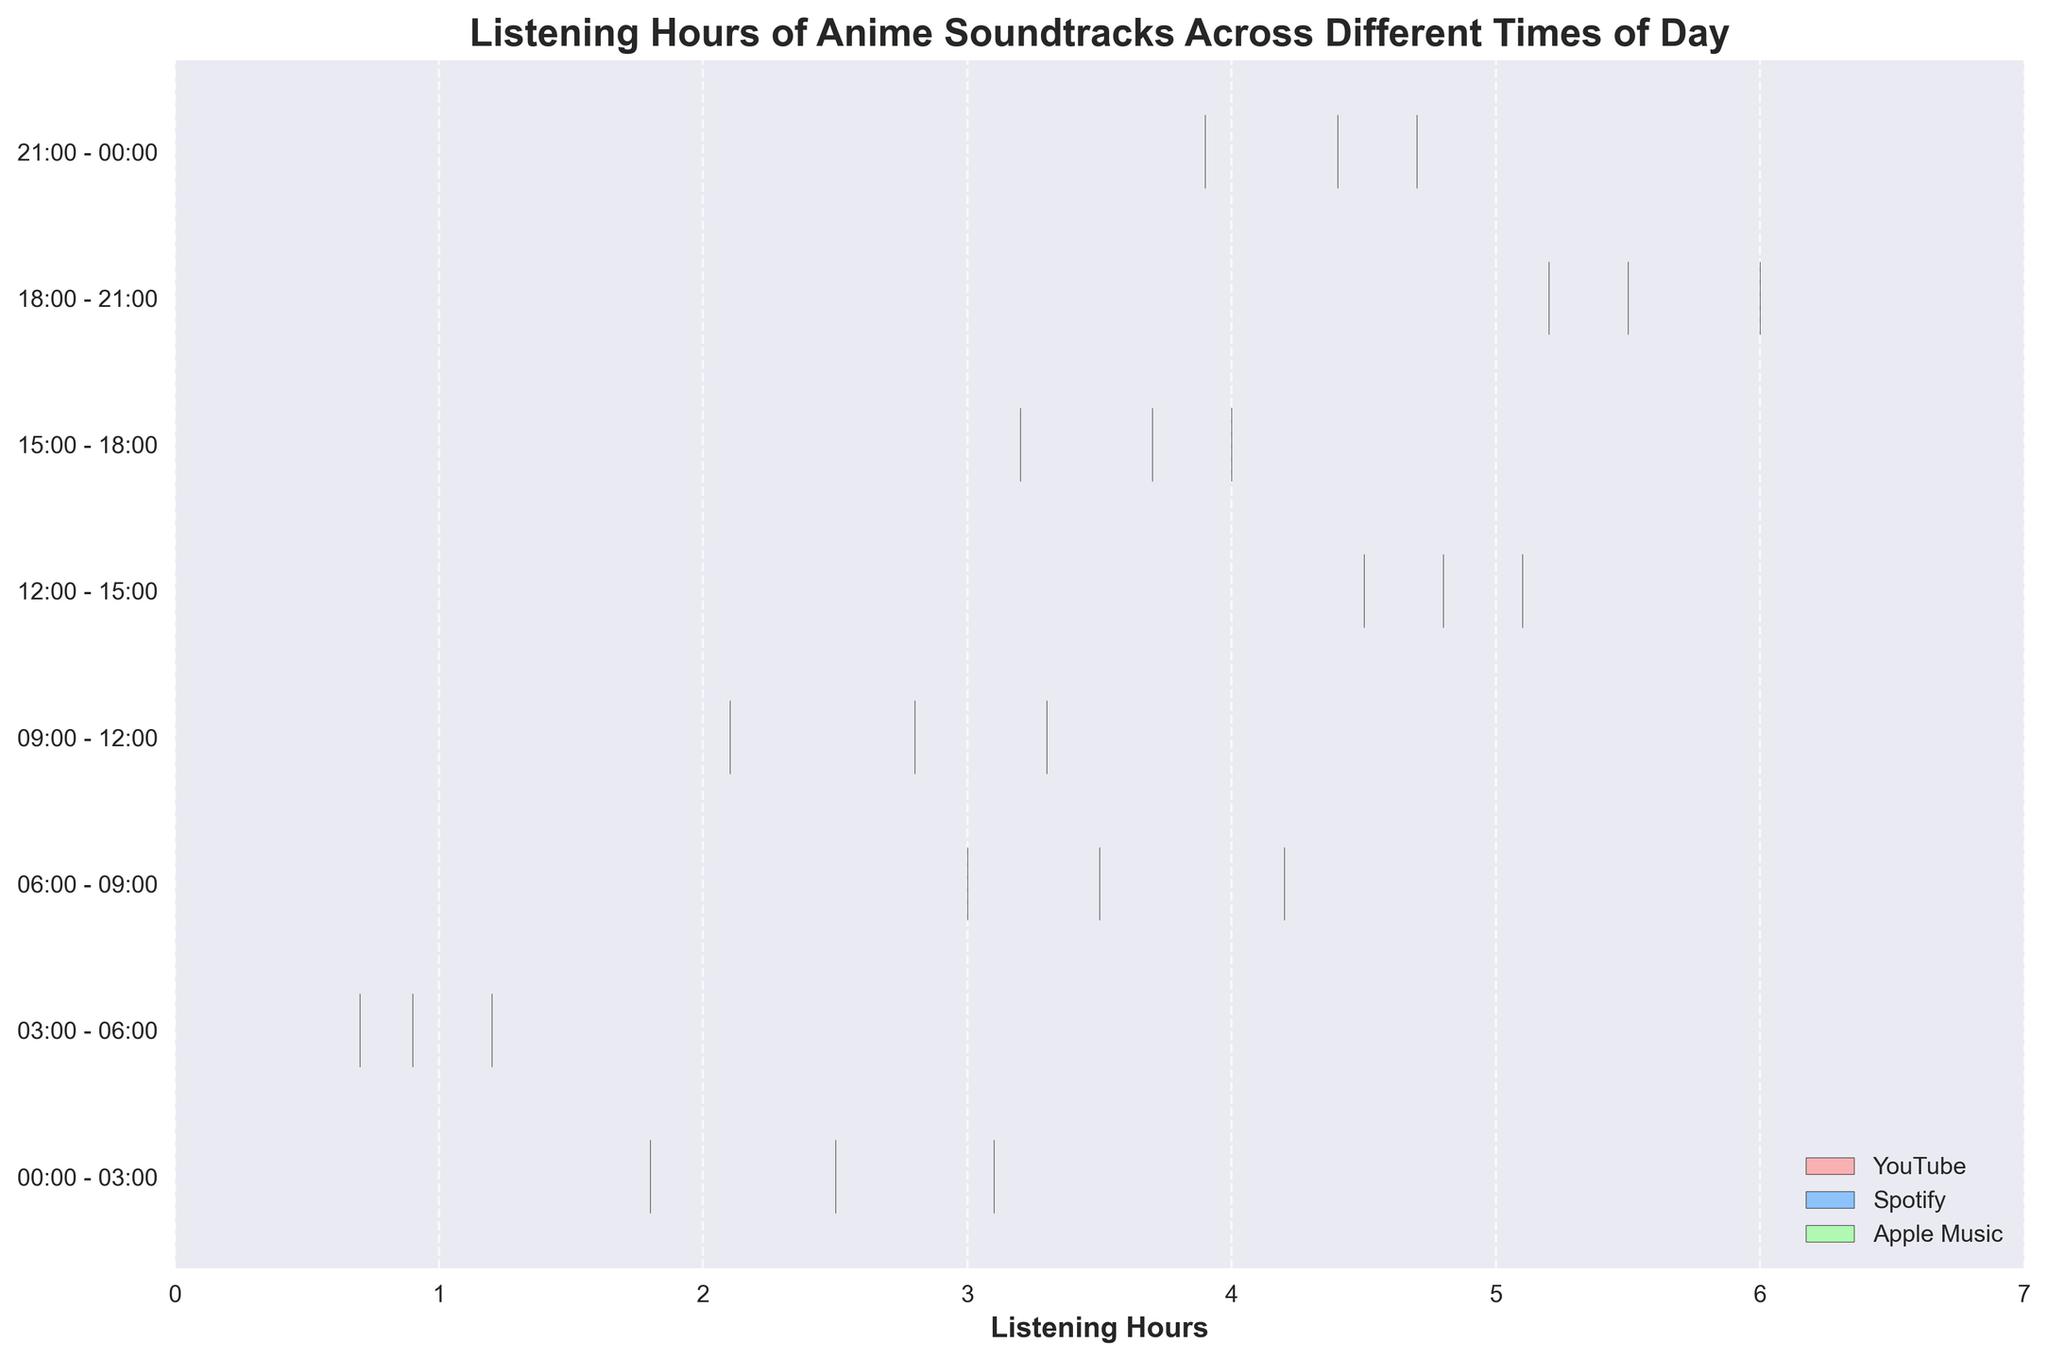Which time of day shows the highest listening hours for anime soundtracks on YouTube? The chart title is "Listening Hours of Anime Soundtracks Across Different Times of Day". By analyzing the shades of the violin plots across different time intervals and colors, the time of day with the highest listening hours for YouTube can be identified by finding the widest plot region for YouTube’s color.
Answer: 18:00 - 21:00 How do the listening hours of Spotify between 12:00 - 15:00 and 21:00 - 00:00 compare? The chart uses different colors for each source. To compare Spotify, identify the corresponding color and observe the widths of the violin plots at these two times. Between 12:00 - 15:00, Spotify shows a wider distribution compared to 21:00 - 00:00.
Answer: 12:00 - 15:00 is higher What is the average listening hour of anime soundtracks on Apple Music from 00:00 - 03:00 to 03:00 - 06:00? Add the listening hours for Apple Music from 00:00 - 03:00 (1.8 hours) and 03:00 - 06:00 (0.9 hours), then divide by 2. The average is (1.8 + 0.9) / 2.
Answer: 1.35 hours During which period do people listen to the least anime soundtracks on Apple Music? The chart details periods and their violin width based on Apple Music's color. The narrowest section represents the least listening hours. The smallest plot for any time period for Apple Music (green) is from 03:00 - 06:00.
Answer: 03:00 - 06:00 Which source has the most consistent listening hours across all times of the day? Consistency here means minimum fluctuation in the widths of the violin plots throughout the day. Observing the chart, Spotify (blue) maintains a more uniform width than the others, showing less variation in listening hours.
Answer: Spotify What are the median listening hours for anime soundtracks on YouTube between 09:00 - 12:00? To find the median, locate the violin for YouTube in the specified time (red) and consider that the median is represented around the central bulge of the plot. Visually estimate the midpoint around 2.8 hr.
Answer: 2.8 hours Which time period has the greatest range of listening hours on any platform? Evaluate the overall spread of all violin plots. The widest span observed is for YouTube, Spotify, and Apple Music between 18:00 - 21:00, indicating the largest variation in that time period.
Answer: 18:00 - 21:00 